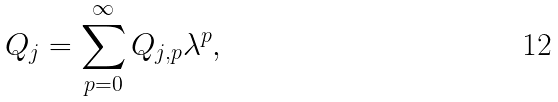Convert formula to latex. <formula><loc_0><loc_0><loc_500><loc_500>Q _ { j } = \sum _ { p = 0 } ^ { \infty } Q _ { j , p } \lambda ^ { p } ,</formula> 